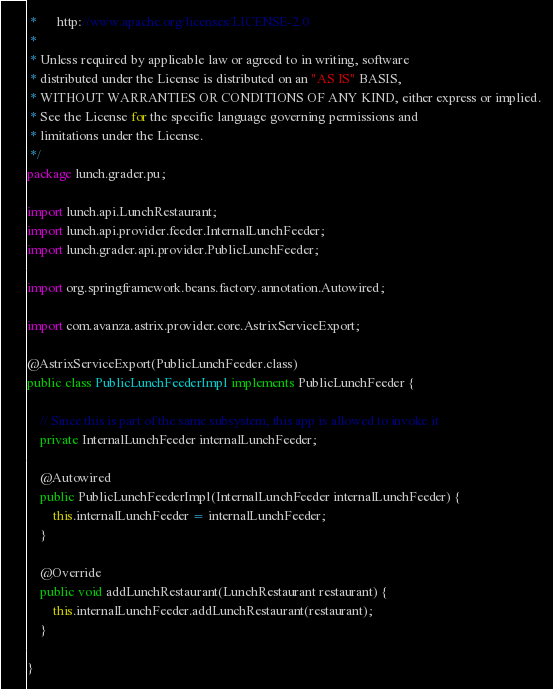<code> <loc_0><loc_0><loc_500><loc_500><_Java_> *      http://www.apache.org/licenses/LICENSE-2.0
 *
 * Unless required by applicable law or agreed to in writing, software
 * distributed under the License is distributed on an "AS IS" BASIS,
 * WITHOUT WARRANTIES OR CONDITIONS OF ANY KIND, either express or implied.
 * See the License for the specific language governing permissions and
 * limitations under the License.
 */
package lunch.grader.pu;

import lunch.api.LunchRestaurant;
import lunch.api.provider.feeder.InternalLunchFeeder;
import lunch.grader.api.provider.PublicLunchFeeder;

import org.springframework.beans.factory.annotation.Autowired;

import com.avanza.astrix.provider.core.AstrixServiceExport;

@AstrixServiceExport(PublicLunchFeeder.class)
public class PublicLunchFeederImpl implements PublicLunchFeeder {

	// Since this is part of the same subsystem, this app is allowed to invoke it
	private InternalLunchFeeder internalLunchFeeder;

	@Autowired
	public PublicLunchFeederImpl(InternalLunchFeeder internalLunchFeeder) {
		this.internalLunchFeeder = internalLunchFeeder;
	}

	@Override
	public void addLunchRestaurant(LunchRestaurant restaurant) {
		this.internalLunchFeeder.addLunchRestaurant(restaurant);
	}

}
</code> 